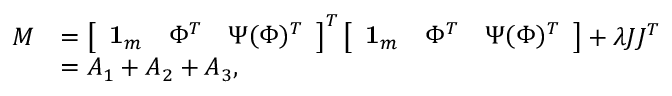<formula> <loc_0><loc_0><loc_500><loc_500>\begin{array} { r l } { M } & { = \left [ \begin{array} { l l l } { { 1 } _ { m } } & { \Phi ^ { T } } & { \Psi ( \Phi ) ^ { T } } \end{array} \right ] ^ { T } \left [ \begin{array} { l l l } { { 1 } _ { m } } & { \Phi ^ { T } } & { \Psi ( \Phi ) ^ { T } } \end{array} \right ] + \lambda J J ^ { T } } \\ & { = A _ { 1 } + A _ { 2 } + A _ { 3 } , } \end{array}</formula> 